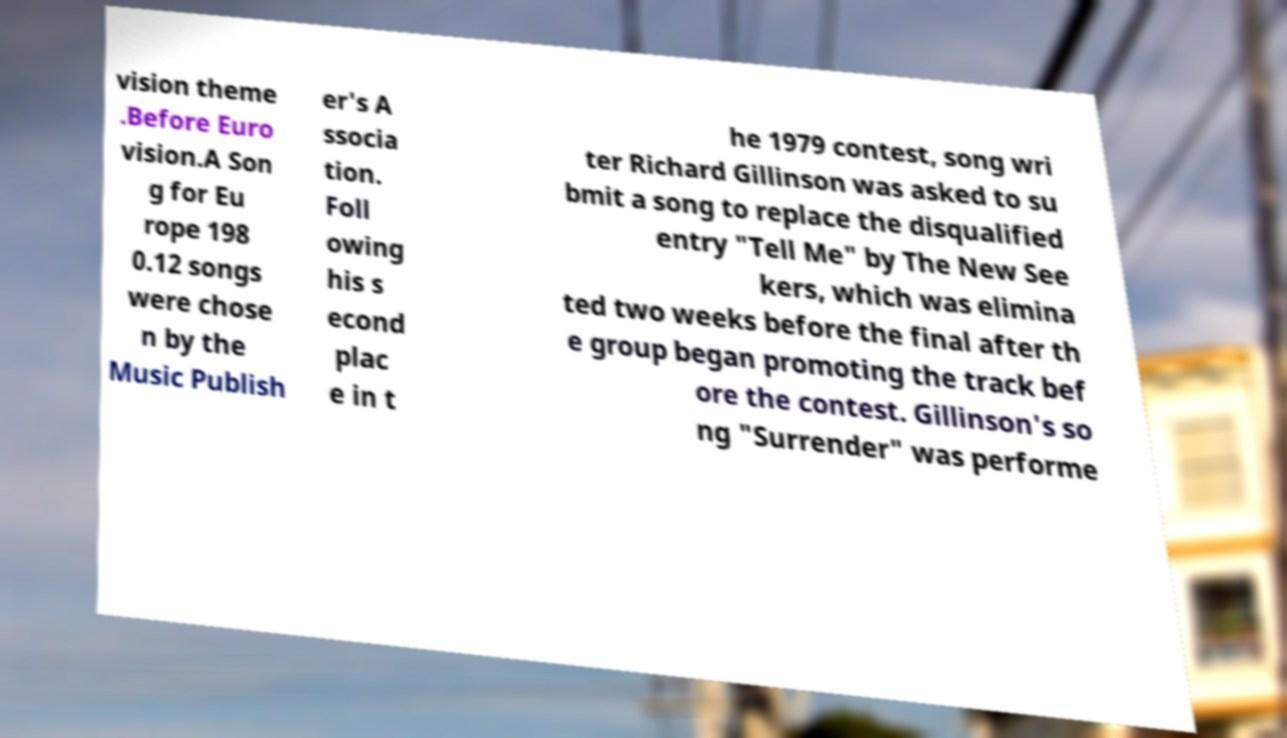What messages or text are displayed in this image? I need them in a readable, typed format. vision theme .Before Euro vision.A Son g for Eu rope 198 0.12 songs were chose n by the Music Publish er's A ssocia tion. Foll owing his s econd plac e in t he 1979 contest, song wri ter Richard Gillinson was asked to su bmit a song to replace the disqualified entry "Tell Me" by The New See kers, which was elimina ted two weeks before the final after th e group began promoting the track bef ore the contest. Gillinson's so ng "Surrender" was performe 